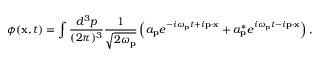<formula> <loc_0><loc_0><loc_500><loc_500>\phi ( x , t ) = \int { \frac { d ^ { 3 } p } { ( 2 \pi ) ^ { 3 } } } { \frac { 1 } { \sqrt { 2 \omega _ { p } } } } \left ( a _ { p } e ^ { - i \omega _ { p } t + i p \cdot x } + a _ { p } ^ { * } e ^ { i \omega _ { p } t - i p \cdot x } \right ) ,</formula> 